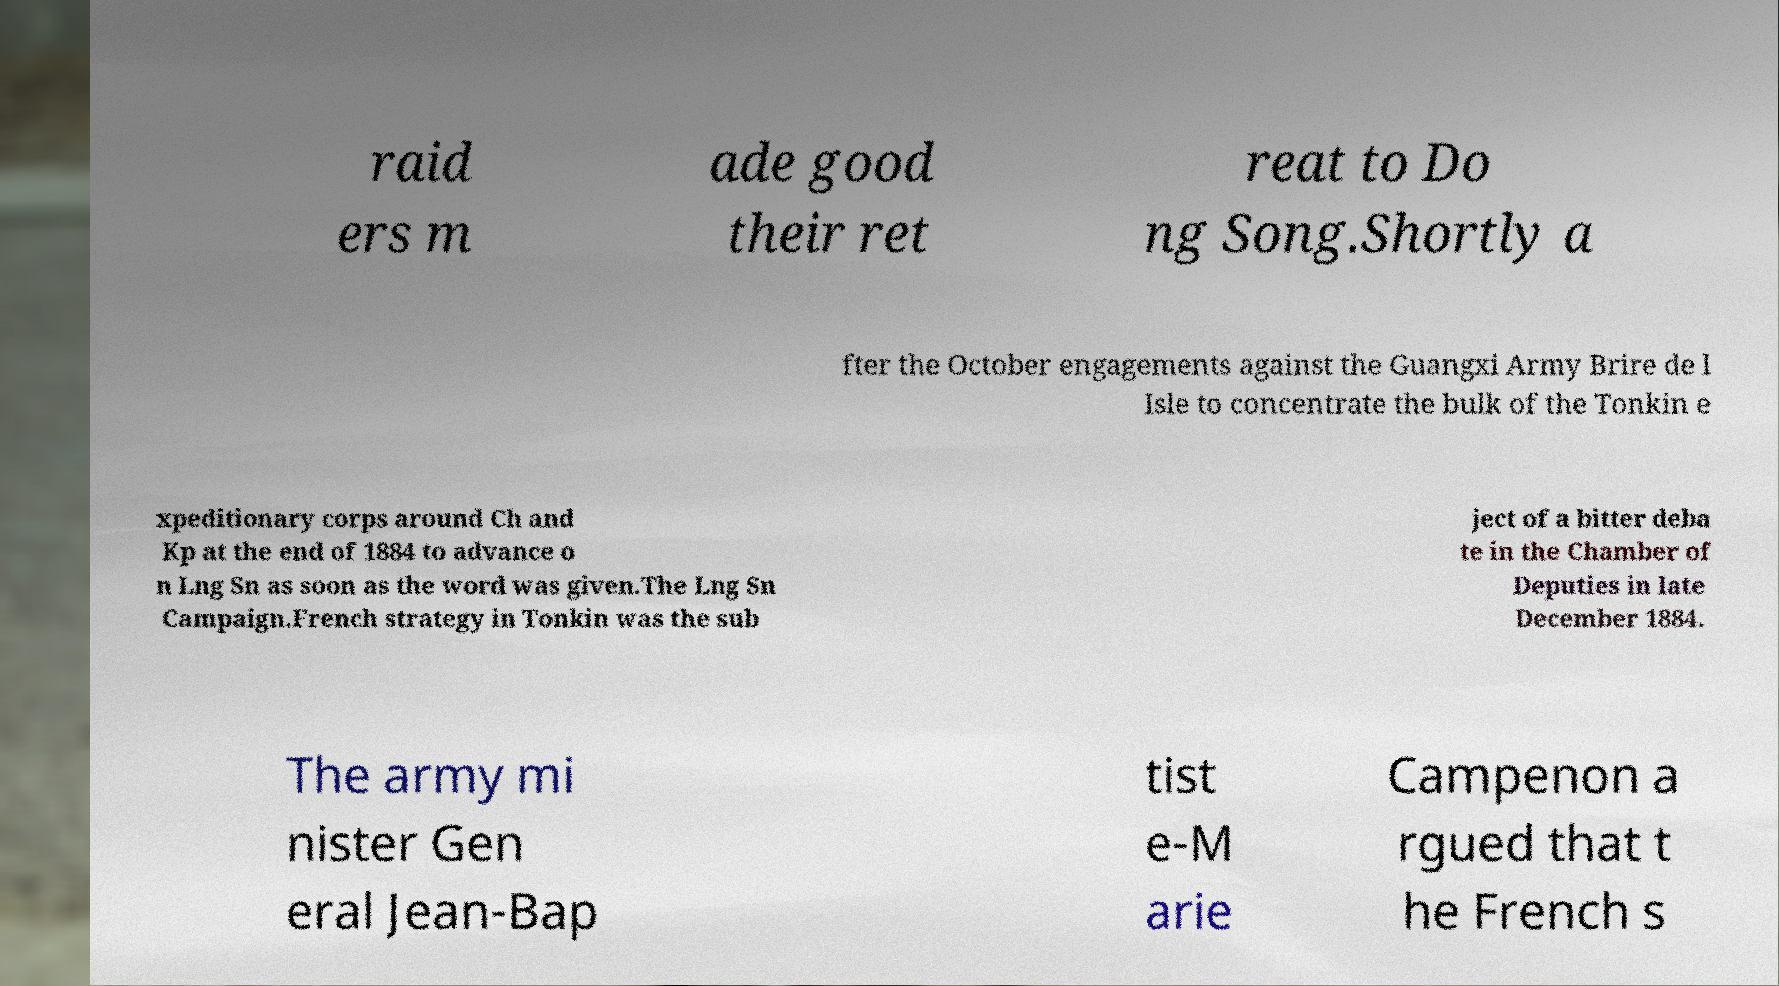What messages or text are displayed in this image? I need them in a readable, typed format. raid ers m ade good their ret reat to Do ng Song.Shortly a fter the October engagements against the Guangxi Army Brire de l Isle to concentrate the bulk of the Tonkin e xpeditionary corps around Ch and Kp at the end of 1884 to advance o n Lng Sn as soon as the word was given.The Lng Sn Campaign.French strategy in Tonkin was the sub ject of a bitter deba te in the Chamber of Deputies in late December 1884. The army mi nister Gen eral Jean-Bap tist e-M arie Campenon a rgued that t he French s 